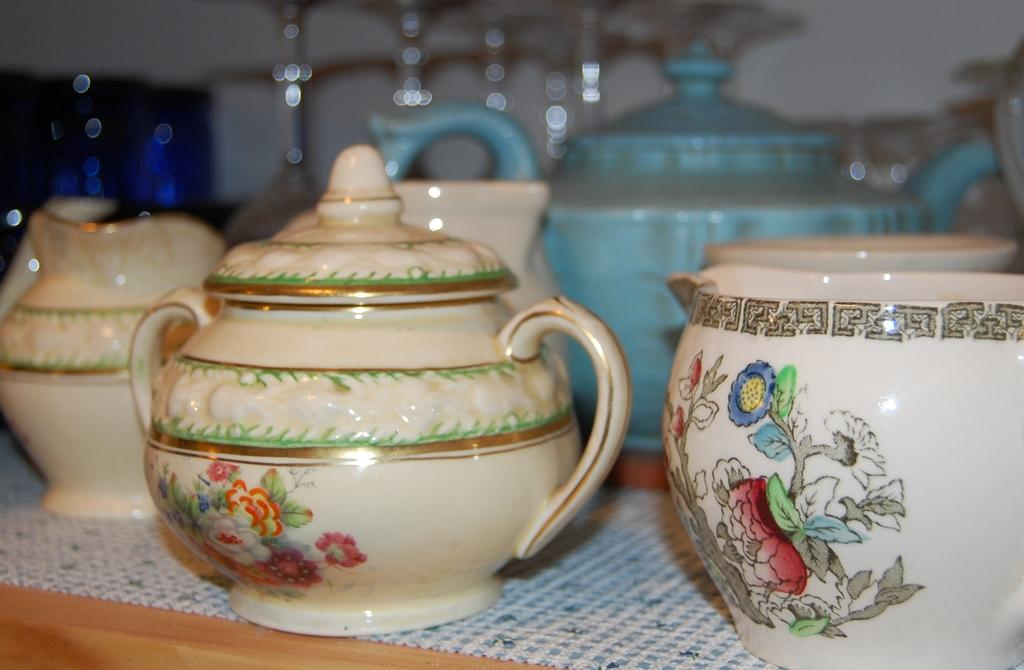What type of furniture is present in the image? There is a table in the image. What is on the table in the image? There are objects on the surface of the table. What can be seen on the wall in the image? There is a white wall in the image. What month is it in the image? The month cannot be determined from the image, as there is no information about the time or date. 